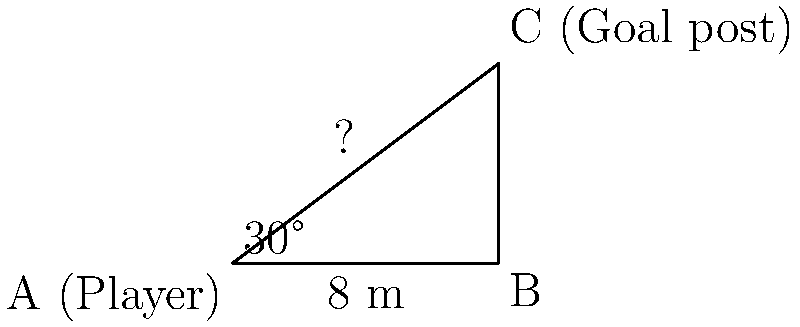You're practicing your free kicks on the training ground in Shamakhi. You're standing at point A, and the goal post is at point C. The distance between you and the base of the goal post (point B) is 8 meters, and the angle between the ground and your line of sight to the top of the goal post is 30°. How far are you from the top of the goal post (AC)? Let's approach this step-by-step:

1) We have a right-angled triangle ABC, where:
   - AB = 8 meters (given)
   - Angle BAC = 30° (given)
   - We need to find AC

2) In a right-angled triangle, we can use the trigonometric ratios. Here, we'll use the cosine ratio:

   $\cos \theta = \frac{\text{adjacent}}{\text{hypotenuse}}$

3) In our case:
   $\cos 30° = \frac{8}{\text{AC}}$

4) We know that $\cos 30° = \frac{\sqrt{3}}{2}$, so:

   $\frac{\sqrt{3}}{2} = \frac{8}{\text{AC}}$

5) Cross multiply:
   $\text{AC} \cdot \frac{\sqrt{3}}{2} = 8$

6) Solve for AC:
   $\text{AC} = \frac{8 \cdot 2}{\sqrt{3}} = \frac{16}{\sqrt{3}}$

7) Simplify:
   $\text{AC} = \frac{16}{\sqrt{3}} \cdot \frac{\sqrt{3}}{\sqrt{3}} = \frac{16\sqrt{3}}{3}$

Therefore, the distance from you (point A) to the top of the goal post (point C) is $\frac{16\sqrt{3}}{3}$ meters.
Answer: $\frac{16\sqrt{3}}{3}$ meters 